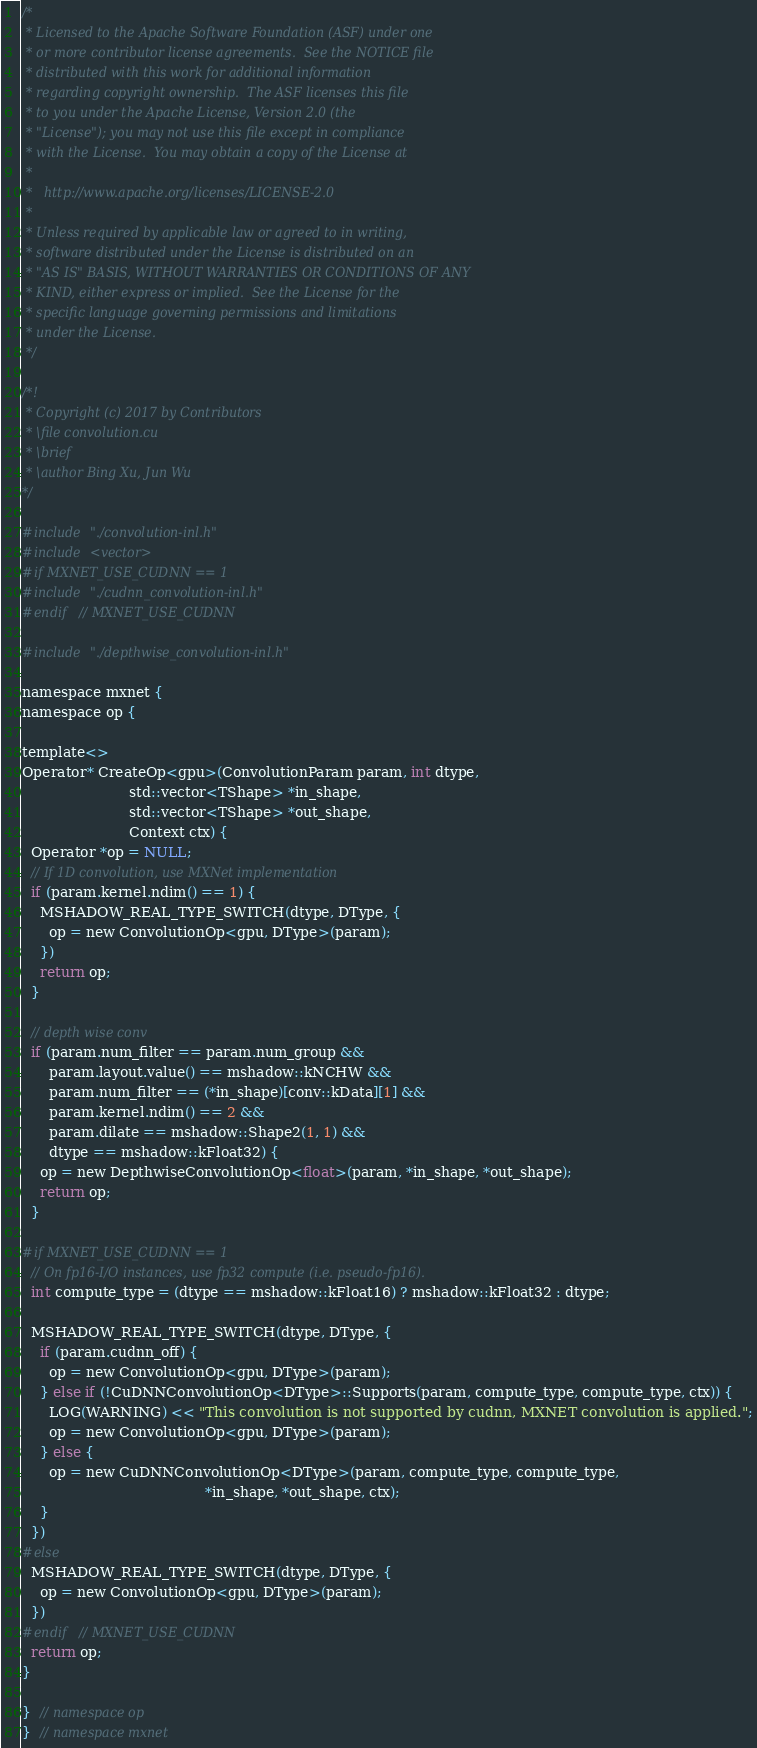<code> <loc_0><loc_0><loc_500><loc_500><_Cuda_>/*
 * Licensed to the Apache Software Foundation (ASF) under one
 * or more contributor license agreements.  See the NOTICE file
 * distributed with this work for additional information
 * regarding copyright ownership.  The ASF licenses this file
 * to you under the Apache License, Version 2.0 (the
 * "License"); you may not use this file except in compliance
 * with the License.  You may obtain a copy of the License at
 *
 *   http://www.apache.org/licenses/LICENSE-2.0
 *
 * Unless required by applicable law or agreed to in writing,
 * software distributed under the License is distributed on an
 * "AS IS" BASIS, WITHOUT WARRANTIES OR CONDITIONS OF ANY
 * KIND, either express or implied.  See the License for the
 * specific language governing permissions and limitations
 * under the License.
 */

/*!
 * Copyright (c) 2017 by Contributors
 * \file convolution.cu
 * \brief
 * \author Bing Xu, Jun Wu
*/

#include "./convolution-inl.h"
#include <vector>
#if MXNET_USE_CUDNN == 1
#include "./cudnn_convolution-inl.h"
#endif  // MXNET_USE_CUDNN

#include "./depthwise_convolution-inl.h"

namespace mxnet {
namespace op {

template<>
Operator* CreateOp<gpu>(ConvolutionParam param, int dtype,
                        std::vector<TShape> *in_shape,
                        std::vector<TShape> *out_shape,
                        Context ctx) {
  Operator *op = NULL;
  // If 1D convolution, use MXNet implementation
  if (param.kernel.ndim() == 1) {
    MSHADOW_REAL_TYPE_SWITCH(dtype, DType, {
      op = new ConvolutionOp<gpu, DType>(param);
    })
    return op;
  }

  // depth wise conv
  if (param.num_filter == param.num_group &&
      param.layout.value() == mshadow::kNCHW &&
      param.num_filter == (*in_shape)[conv::kData][1] &&
      param.kernel.ndim() == 2 &&
      param.dilate == mshadow::Shape2(1, 1) &&
      dtype == mshadow::kFloat32) {
    op = new DepthwiseConvolutionOp<float>(param, *in_shape, *out_shape);
    return op;
  }

#if MXNET_USE_CUDNN == 1
  // On fp16-I/O instances, use fp32 compute (i.e. pseudo-fp16).
  int compute_type = (dtype == mshadow::kFloat16) ? mshadow::kFloat32 : dtype;

  MSHADOW_REAL_TYPE_SWITCH(dtype, DType, {
    if (param.cudnn_off) {
      op = new ConvolutionOp<gpu, DType>(param);
    } else if (!CuDNNConvolutionOp<DType>::Supports(param, compute_type, compute_type, ctx)) {
      LOG(WARNING) << "This convolution is not supported by cudnn, MXNET convolution is applied.";
      op = new ConvolutionOp<gpu, DType>(param);
    } else {
      op = new CuDNNConvolutionOp<DType>(param, compute_type, compute_type,
                                         *in_shape, *out_shape, ctx);
    }
  })
#else
  MSHADOW_REAL_TYPE_SWITCH(dtype, DType, {
    op = new ConvolutionOp<gpu, DType>(param);
  })
#endif  // MXNET_USE_CUDNN
  return op;
}

}  // namespace op
}  // namespace mxnet

</code> 